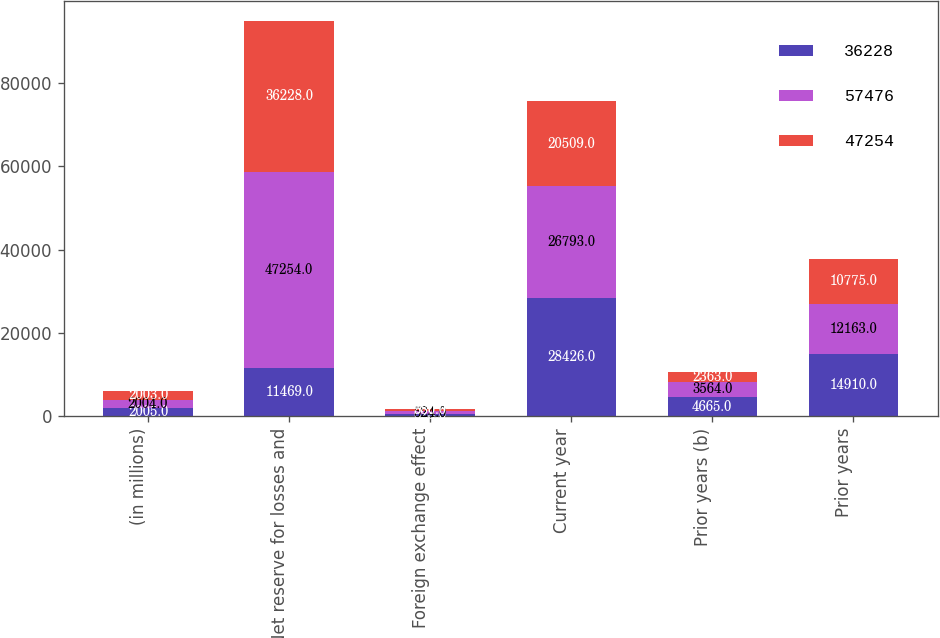Convert chart. <chart><loc_0><loc_0><loc_500><loc_500><stacked_bar_chart><ecel><fcel>(in millions)<fcel>Net reserve for losses and<fcel>Foreign exchange effect<fcel>Current year<fcel>Prior years (b)<fcel>Prior years<nl><fcel>36228<fcel>2005<fcel>11469<fcel>628<fcel>28426<fcel>4665<fcel>14910<nl><fcel>57476<fcel>2004<fcel>47254<fcel>524<fcel>26793<fcel>3564<fcel>12163<nl><fcel>47254<fcel>2003<fcel>36228<fcel>580<fcel>20509<fcel>2363<fcel>10775<nl></chart> 